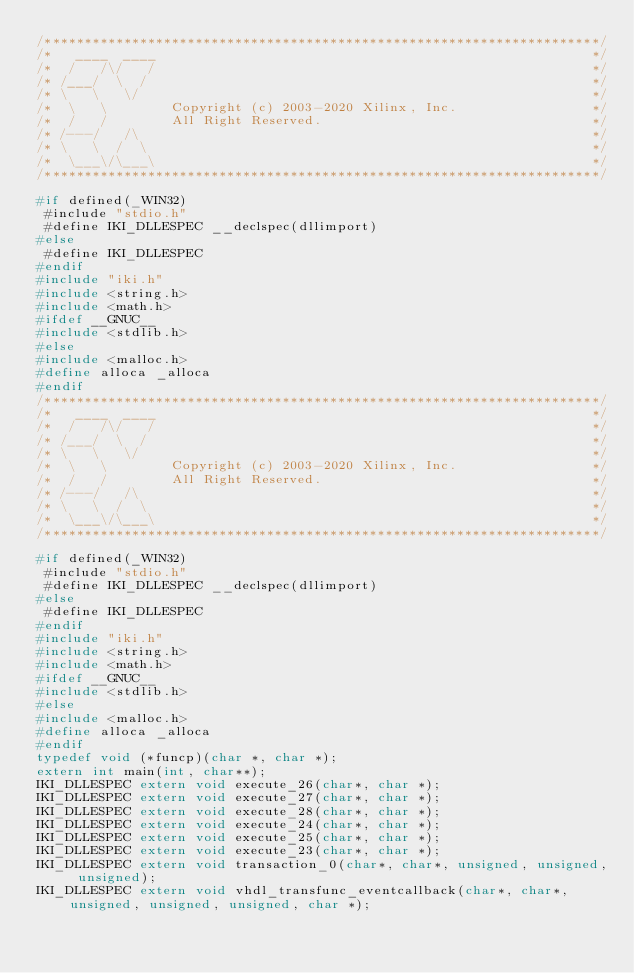<code> <loc_0><loc_0><loc_500><loc_500><_C_>/**********************************************************************/
/*   ____  ____                                                       */
/*  /   /\/   /                                                       */
/* /___/  \  /                                                        */
/* \   \   \/                                                         */
/*  \   \        Copyright (c) 2003-2020 Xilinx, Inc.                 */
/*  /   /        All Right Reserved.                                  */
/* /---/   /\                                                         */
/* \   \  /  \                                                        */
/*  \___\/\___\                                                       */
/**********************************************************************/

#if defined(_WIN32)
 #include "stdio.h"
 #define IKI_DLLESPEC __declspec(dllimport)
#else
 #define IKI_DLLESPEC
#endif
#include "iki.h"
#include <string.h>
#include <math.h>
#ifdef __GNUC__
#include <stdlib.h>
#else
#include <malloc.h>
#define alloca _alloca
#endif
/**********************************************************************/
/*   ____  ____                                                       */
/*  /   /\/   /                                                       */
/* /___/  \  /                                                        */
/* \   \   \/                                                         */
/*  \   \        Copyright (c) 2003-2020 Xilinx, Inc.                 */
/*  /   /        All Right Reserved.                                  */
/* /---/   /\                                                         */
/* \   \  /  \                                                        */
/*  \___\/\___\                                                       */
/**********************************************************************/

#if defined(_WIN32)
 #include "stdio.h"
 #define IKI_DLLESPEC __declspec(dllimport)
#else
 #define IKI_DLLESPEC
#endif
#include "iki.h"
#include <string.h>
#include <math.h>
#ifdef __GNUC__
#include <stdlib.h>
#else
#include <malloc.h>
#define alloca _alloca
#endif
typedef void (*funcp)(char *, char *);
extern int main(int, char**);
IKI_DLLESPEC extern void execute_26(char*, char *);
IKI_DLLESPEC extern void execute_27(char*, char *);
IKI_DLLESPEC extern void execute_28(char*, char *);
IKI_DLLESPEC extern void execute_24(char*, char *);
IKI_DLLESPEC extern void execute_25(char*, char *);
IKI_DLLESPEC extern void execute_23(char*, char *);
IKI_DLLESPEC extern void transaction_0(char*, char*, unsigned, unsigned, unsigned);
IKI_DLLESPEC extern void vhdl_transfunc_eventcallback(char*, char*, unsigned, unsigned, unsigned, char *);</code> 